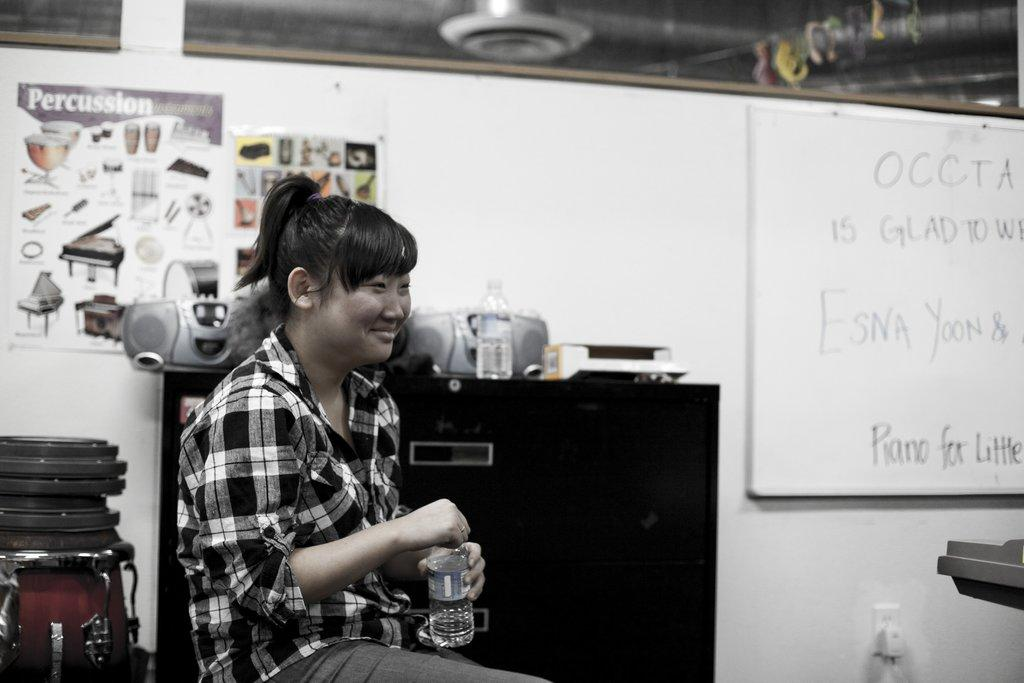<image>
Share a concise interpretation of the image provided. a poster with the word percussion is behind a lady 